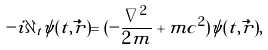<formula> <loc_0><loc_0><loc_500><loc_500>- i \partial _ { t } \psi ( t , \vec { r } ) = ( - \frac { \nabla ^ { 2 } } { 2 m } + m c ^ { 2 } ) \psi ( t , \vec { r } ) ,</formula> 